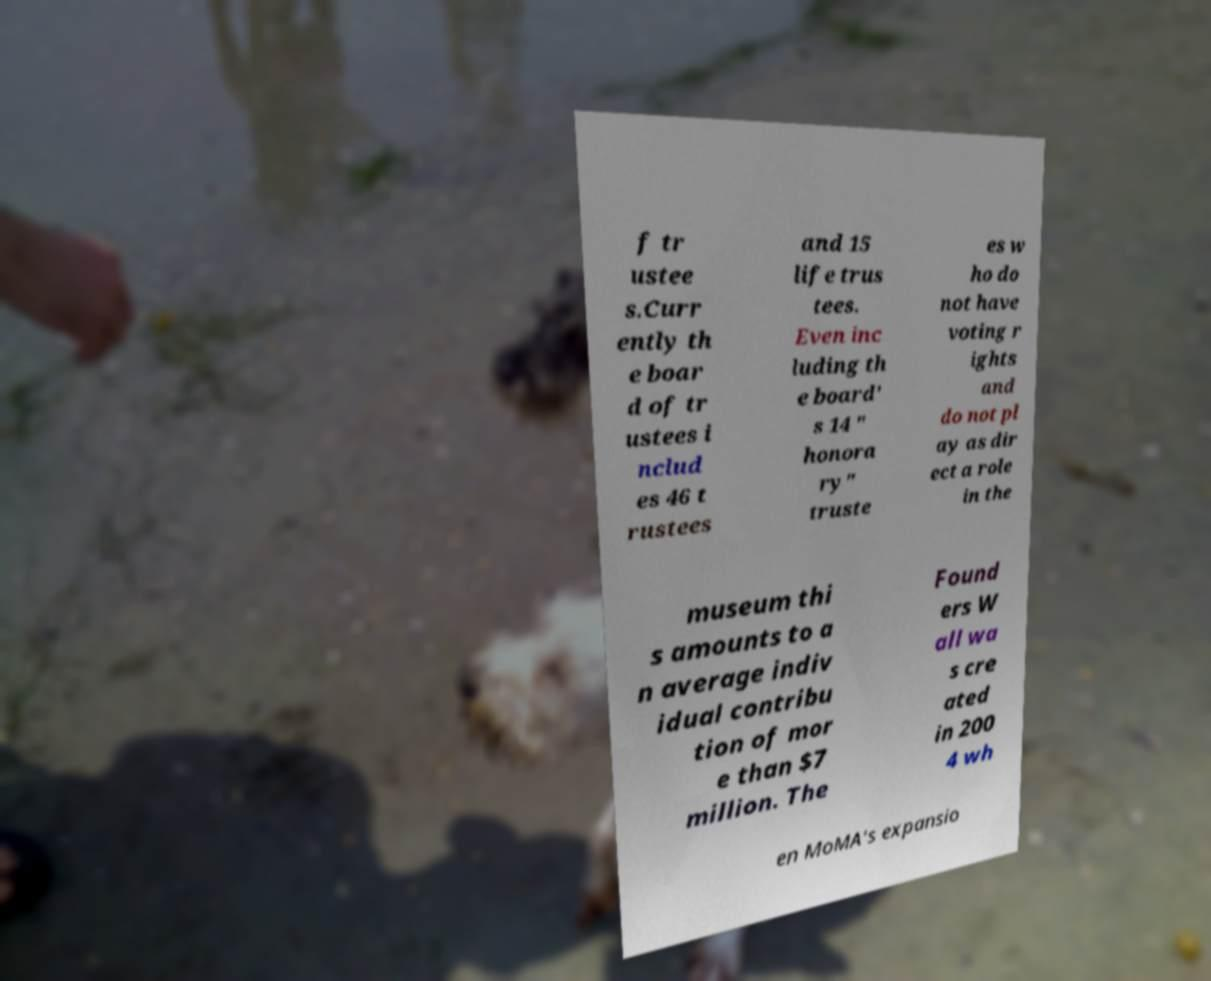Can you read and provide the text displayed in the image?This photo seems to have some interesting text. Can you extract and type it out for me? f tr ustee s.Curr ently th e boar d of tr ustees i nclud es 46 t rustees and 15 life trus tees. Even inc luding th e board' s 14 " honora ry" truste es w ho do not have voting r ights and do not pl ay as dir ect a role in the museum thi s amounts to a n average indiv idual contribu tion of mor e than $7 million. The Found ers W all wa s cre ated in 200 4 wh en MoMA's expansio 